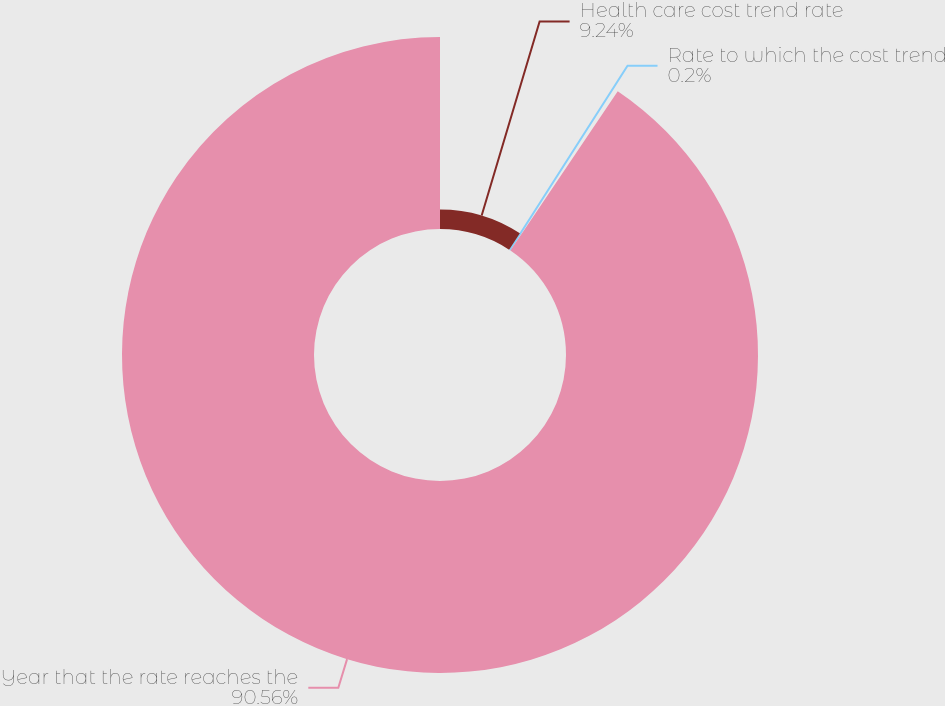Convert chart. <chart><loc_0><loc_0><loc_500><loc_500><pie_chart><fcel>Health care cost trend rate<fcel>Rate to which the cost trend<fcel>Year that the rate reaches the<nl><fcel>9.24%<fcel>0.2%<fcel>90.56%<nl></chart> 